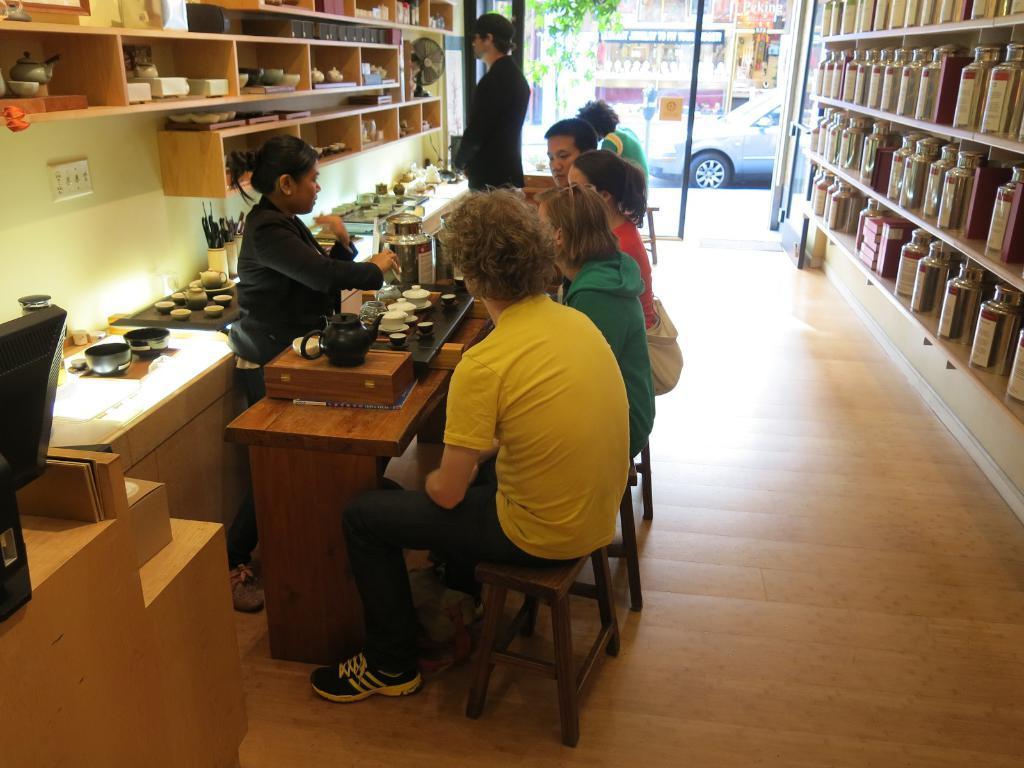Can you describe this image briefly? In this picture I can see couple of them standing and few are sitting on the stools and I can see tables, few items and bowls on the tables and from the glass door I can see a car and another building and I can see a plant and looks like a monitor on the left side of the picture and I can see a table fan. 